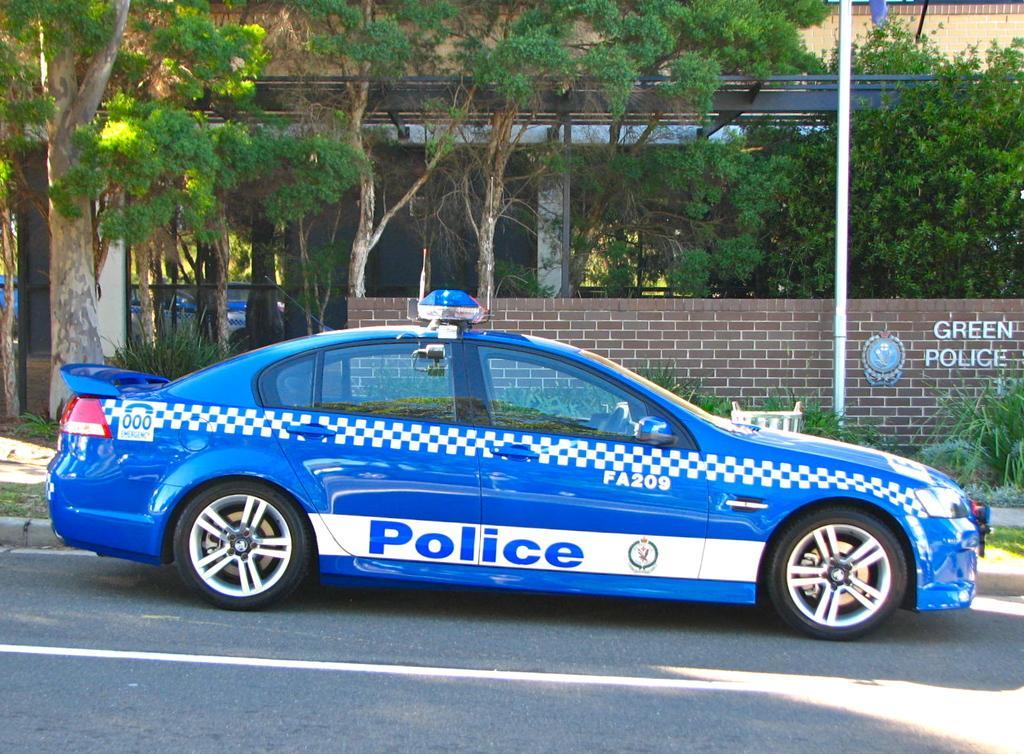Please provide a concise description of this image. In the center of the center of the image we can see a car on the road. On the car, we can see some text. In the background there is a building, wall, one pole, trees, plants and a few other objects. And we can see some text on the wall. 